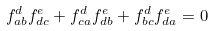Convert formula to latex. <formula><loc_0><loc_0><loc_500><loc_500>f ^ { d } _ { a b } f ^ { e } _ { d c } + f ^ { d } _ { c a } f ^ { e } _ { d b } + f ^ { d } _ { b c } f ^ { e } _ { d a } = 0</formula> 